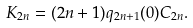Convert formula to latex. <formula><loc_0><loc_0><loc_500><loc_500>K _ { 2 n } = ( 2 n + 1 ) q _ { 2 n + 1 } ( 0 ) C _ { 2 n } .</formula> 